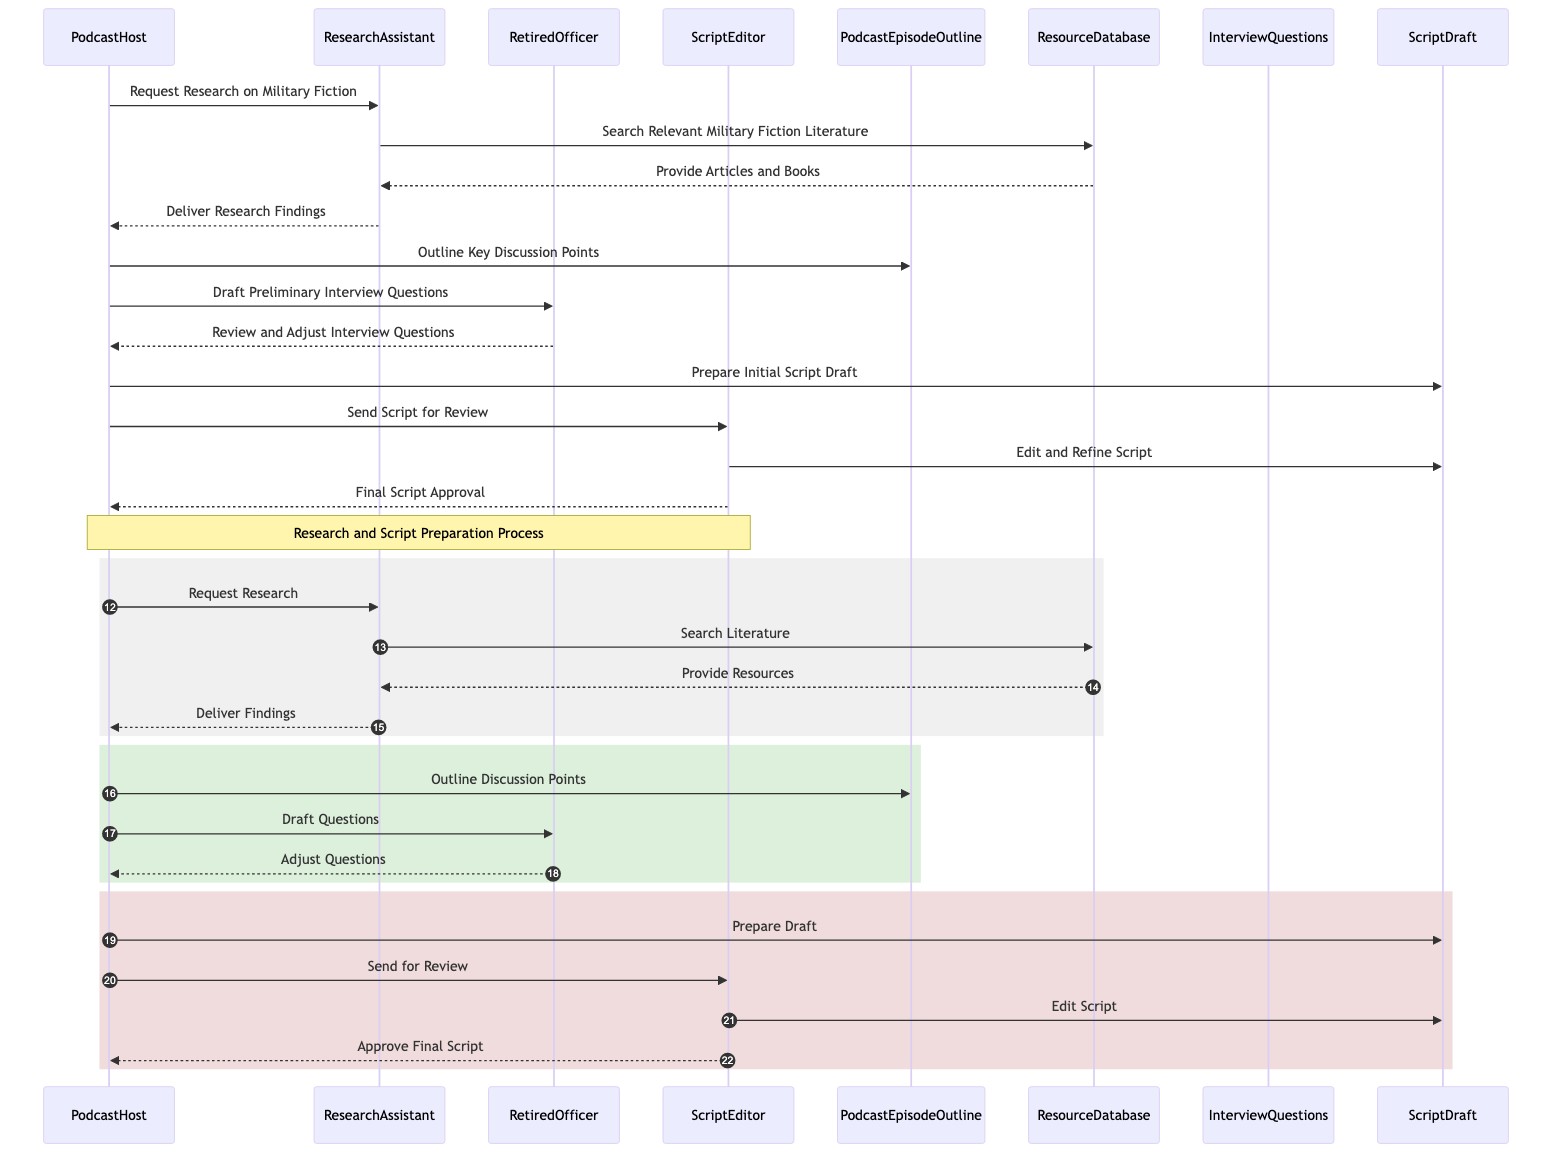What is the first action taken in the diagram? The first action depicted in the diagram is a request for research on military fiction from the PodcastHost to the ResearchAssistant. This can be seen as the initial message that starts the sequence of actions.
Answer: Request Research on Military Fiction How many actors are involved in the sequence? The diagram includes four distinct actors: PodcastHost, ResearchAssistant, RetiredOfficer, and ScriptEditor. This information is drawn directly from the list of participants in the sequence.
Answer: Four What does the ResearchAssistant do after receiving the request? After receiving the request from the PodcastHost, the ResearchAssistant performs a search for relevant military fiction literature by interacting with the ResourceDatabase. This step is essential for gathering necessary research material.
Answer: Search Relevant Military Fiction Literature Which object does the ScriptEditor interact with? The ScriptEditor interacts with the ScriptDraft object when editing and refining the script. This step involves taking the draft created by the PodcastHost and making improvements before final approval.
Answer: ScriptDraft What is the final action taken in the sequence? The last action in the sequence is the ScriptEditor providing final script approval back to the PodcastHost, completing the scripted preparation process. This indicates that the script has been reviewed and is ready for the podcast episode.
Answer: Final Script Approval How many messages are exchanged between the PodcastHost and the RetiredOfficer? There are two messages exchanged between the PodcastHost and RetiredOfficer: one where the PodcastHost drafts preliminary interview questions and another where the RetiredOfficer reviews and adjusts those questions. This indicates an iterative process of refining the interview content.
Answer: Two What is the role of the ResourceDatabase in the process? The ResourceDatabase plays a critical role in providing articles and books to the ResearchAssistant after the search for relevant military fiction literature. This information supply is essential for the research process.
Answer: Provide Articles and Books Which action occurs directly after delivering research findings? After the research findings are delivered to the PodcastHost, the next action taken is the outlining of key discussion points, marking the transition to the script preparation phase. This connection emphasizes the interdependency between research and script development.
Answer: Outline Key Discussion Points What is the outcome of the script editing process? The outcome of the script editing process is the final script approval, indicating that the script has been fully reviewed and is deemed ready for production. This step is crucial for ensuring content quality.
Answer: Final Script Approval 